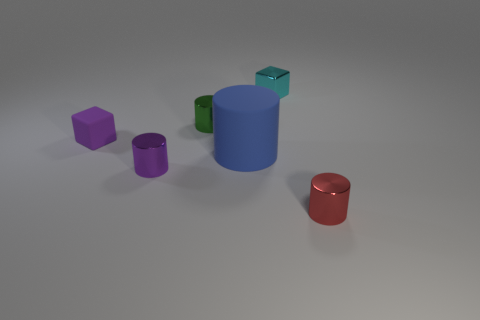What number of small objects are red metal balls or purple rubber objects?
Your answer should be very brief. 1. Does the large thing have the same shape as the purple shiny object?
Your response must be concise. Yes. How many metallic things are both behind the small red thing and in front of the small cyan thing?
Your answer should be compact. 2. Are there any other things of the same color as the tiny rubber block?
Offer a very short reply. Yes. The small green thing that is made of the same material as the small red thing is what shape?
Ensure brevity in your answer.  Cylinder. Does the purple matte cube have the same size as the purple cylinder?
Keep it short and to the point. Yes. Is the material of the small cube that is in front of the green shiny cylinder the same as the big blue thing?
Provide a short and direct response. Yes. Are there any other things that are the same material as the big blue cylinder?
Provide a short and direct response. Yes. There is a tiny metal cylinder that is right of the metal cylinder that is behind the tiny purple shiny thing; how many purple objects are on the right side of it?
Offer a very short reply. 0. There is a rubber thing that is left of the purple cylinder; does it have the same shape as the blue matte thing?
Your answer should be compact. No. 